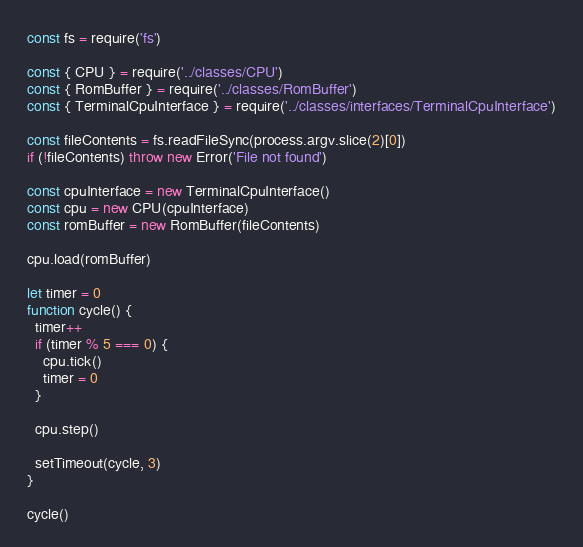<code> <loc_0><loc_0><loc_500><loc_500><_JavaScript_>const fs = require('fs')

const { CPU } = require('../classes/CPU')
const { RomBuffer } = require('../classes/RomBuffer')
const { TerminalCpuInterface } = require('../classes/interfaces/TerminalCpuInterface')

const fileContents = fs.readFileSync(process.argv.slice(2)[0])
if (!fileContents) throw new Error('File not found')

const cpuInterface = new TerminalCpuInterface()
const cpu = new CPU(cpuInterface)
const romBuffer = new RomBuffer(fileContents)

cpu.load(romBuffer)

let timer = 0
function cycle() {
  timer++
  if (timer % 5 === 0) {
    cpu.tick()
    timer = 0
  }

  cpu.step()

  setTimeout(cycle, 3)
}

cycle()
</code> 